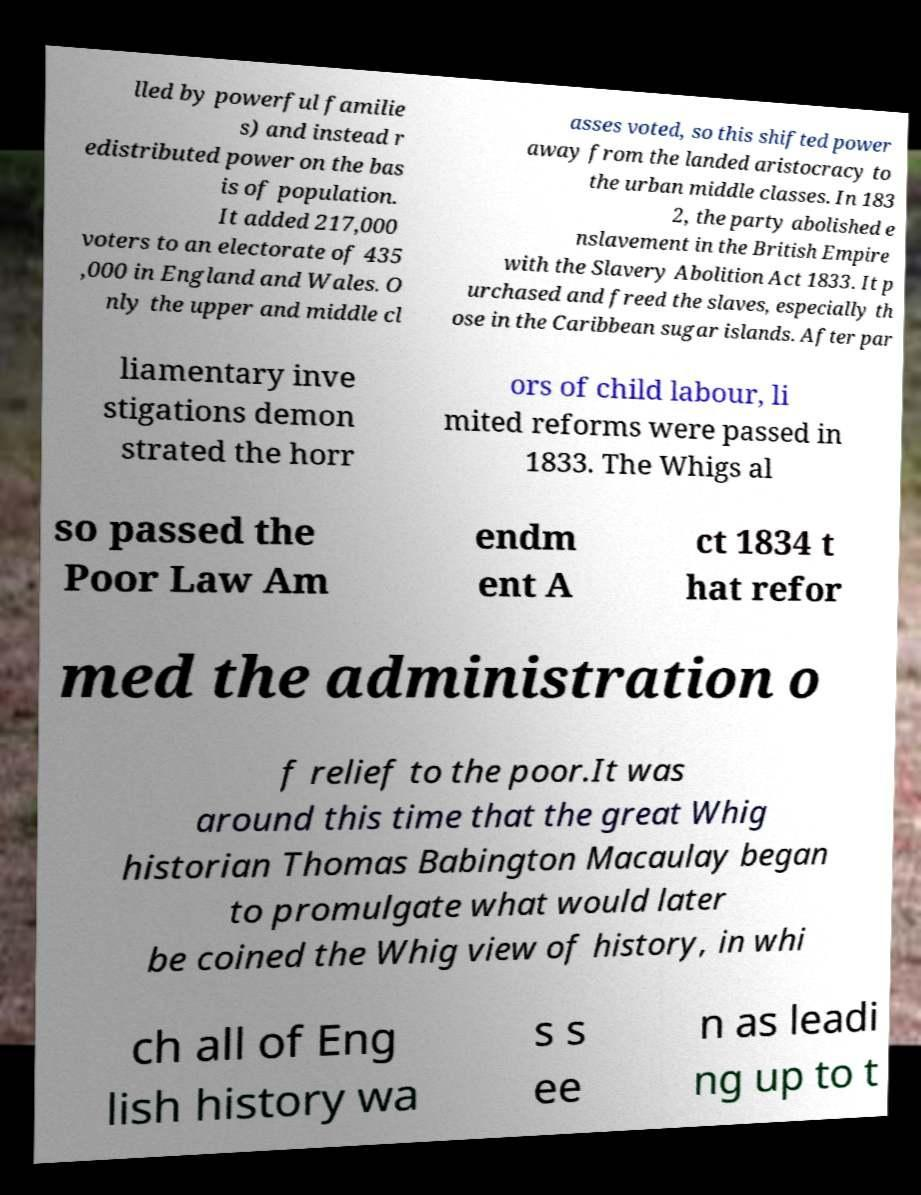Can you read and provide the text displayed in the image?This photo seems to have some interesting text. Can you extract and type it out for me? lled by powerful familie s) and instead r edistributed power on the bas is of population. It added 217,000 voters to an electorate of 435 ,000 in England and Wales. O nly the upper and middle cl asses voted, so this shifted power away from the landed aristocracy to the urban middle classes. In 183 2, the party abolished e nslavement in the British Empire with the Slavery Abolition Act 1833. It p urchased and freed the slaves, especially th ose in the Caribbean sugar islands. After par liamentary inve stigations demon strated the horr ors of child labour, li mited reforms were passed in 1833. The Whigs al so passed the Poor Law Am endm ent A ct 1834 t hat refor med the administration o f relief to the poor.It was around this time that the great Whig historian Thomas Babington Macaulay began to promulgate what would later be coined the Whig view of history, in whi ch all of Eng lish history wa s s ee n as leadi ng up to t 